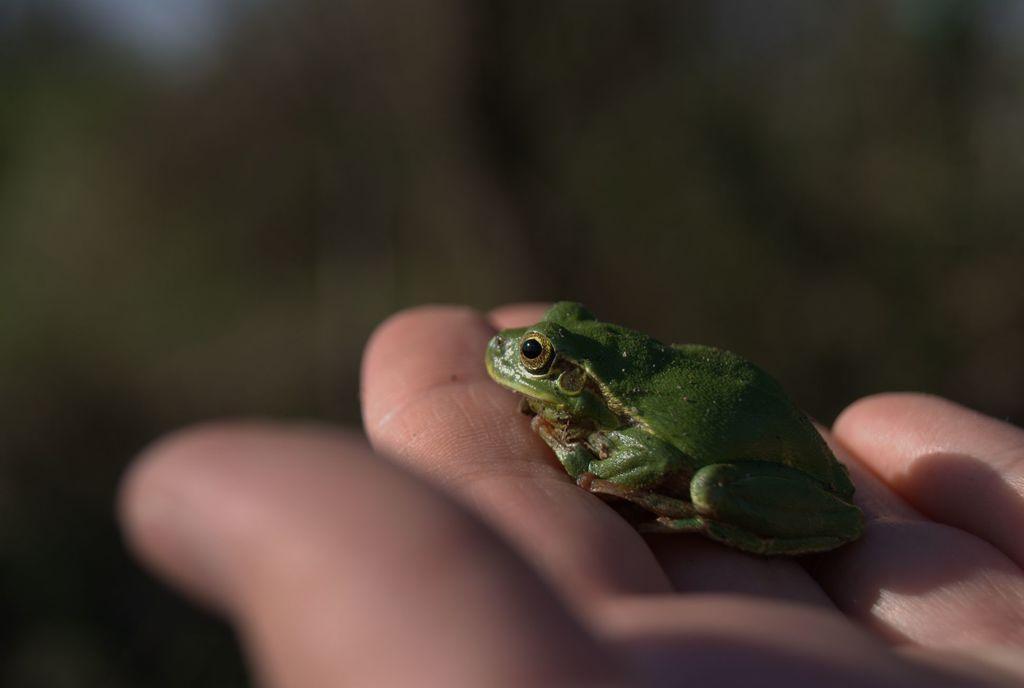Can you describe this image briefly? In this image we can see a frog on a person's fingers. In the background the image is blur. 